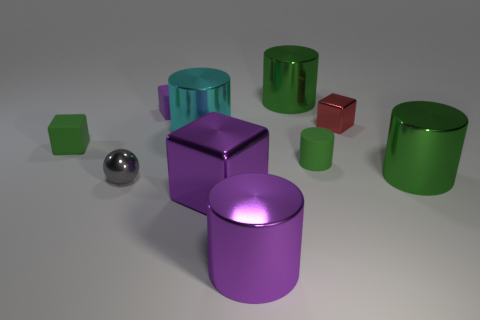Subtract all small cylinders. How many cylinders are left? 4 Subtract all purple blocks. How many blocks are left? 2 Subtract all cubes. How many objects are left? 6 Subtract all brown blocks. How many purple cylinders are left? 1 Subtract 0 blue balls. How many objects are left? 10 Subtract 4 cubes. How many cubes are left? 0 Subtract all red blocks. Subtract all red spheres. How many blocks are left? 3 Subtract all small red cubes. Subtract all small gray balls. How many objects are left? 8 Add 3 green rubber objects. How many green rubber objects are left? 5 Add 1 small blocks. How many small blocks exist? 4 